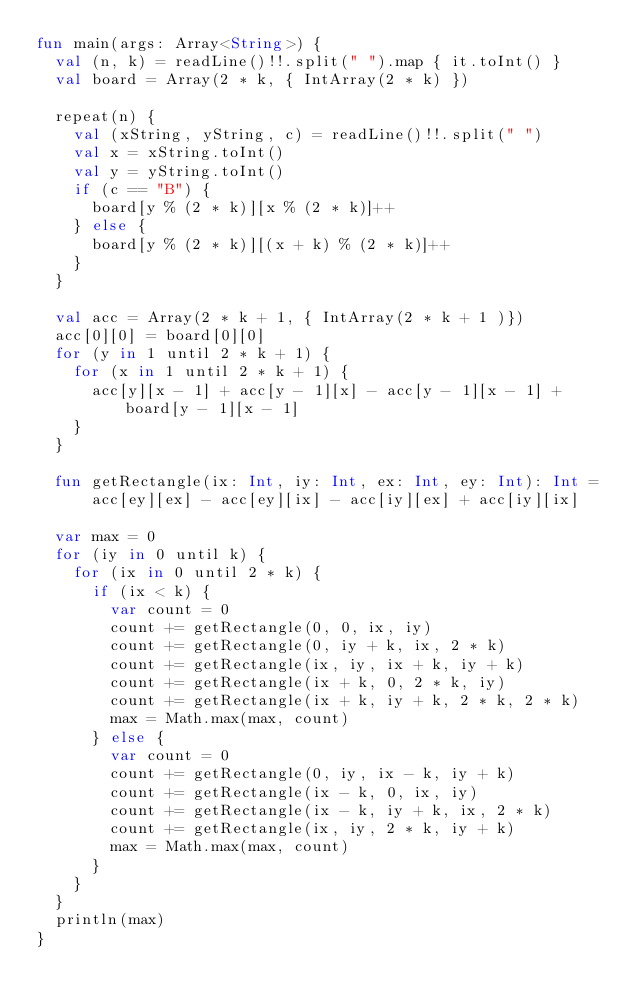<code> <loc_0><loc_0><loc_500><loc_500><_Kotlin_>fun main(args: Array<String>) {
  val (n, k) = readLine()!!.split(" ").map { it.toInt() }
  val board = Array(2 * k, { IntArray(2 * k) })

  repeat(n) {
    val (xString, yString, c) = readLine()!!.split(" ")
    val x = xString.toInt()
    val y = yString.toInt()
    if (c == "B") {
      board[y % (2 * k)][x % (2 * k)]++
    } else {
      board[y % (2 * k)][(x + k) % (2 * k)]++
    }
  }

  val acc = Array(2 * k + 1, { IntArray(2 * k + 1 )})
  acc[0][0] = board[0][0]
  for (y in 1 until 2 * k + 1) {
    for (x in 1 until 2 * k + 1) {
      acc[y][x - 1] + acc[y - 1][x] - acc[y - 1][x - 1] + board[y - 1][x - 1]
    }
  }

  fun getRectangle(ix: Int, iy: Int, ex: Int, ey: Int): Int =
      acc[ey][ex] - acc[ey][ix] - acc[iy][ex] + acc[iy][ix]

  var max = 0
  for (iy in 0 until k) {
    for (ix in 0 until 2 * k) {
      if (ix < k) {
        var count = 0
        count += getRectangle(0, 0, ix, iy)
        count += getRectangle(0, iy + k, ix, 2 * k)
        count += getRectangle(ix, iy, ix + k, iy + k)
        count += getRectangle(ix + k, 0, 2 * k, iy)
        count += getRectangle(ix + k, iy + k, 2 * k, 2 * k)
        max = Math.max(max, count)
      } else {
        var count = 0
        count += getRectangle(0, iy, ix - k, iy + k)
        count += getRectangle(ix - k, 0, ix, iy)
        count += getRectangle(ix - k, iy + k, ix, 2 * k)
        count += getRectangle(ix, iy, 2 * k, iy + k)
        max = Math.max(max, count)
      }
    }
  }
  println(max)
}
</code> 